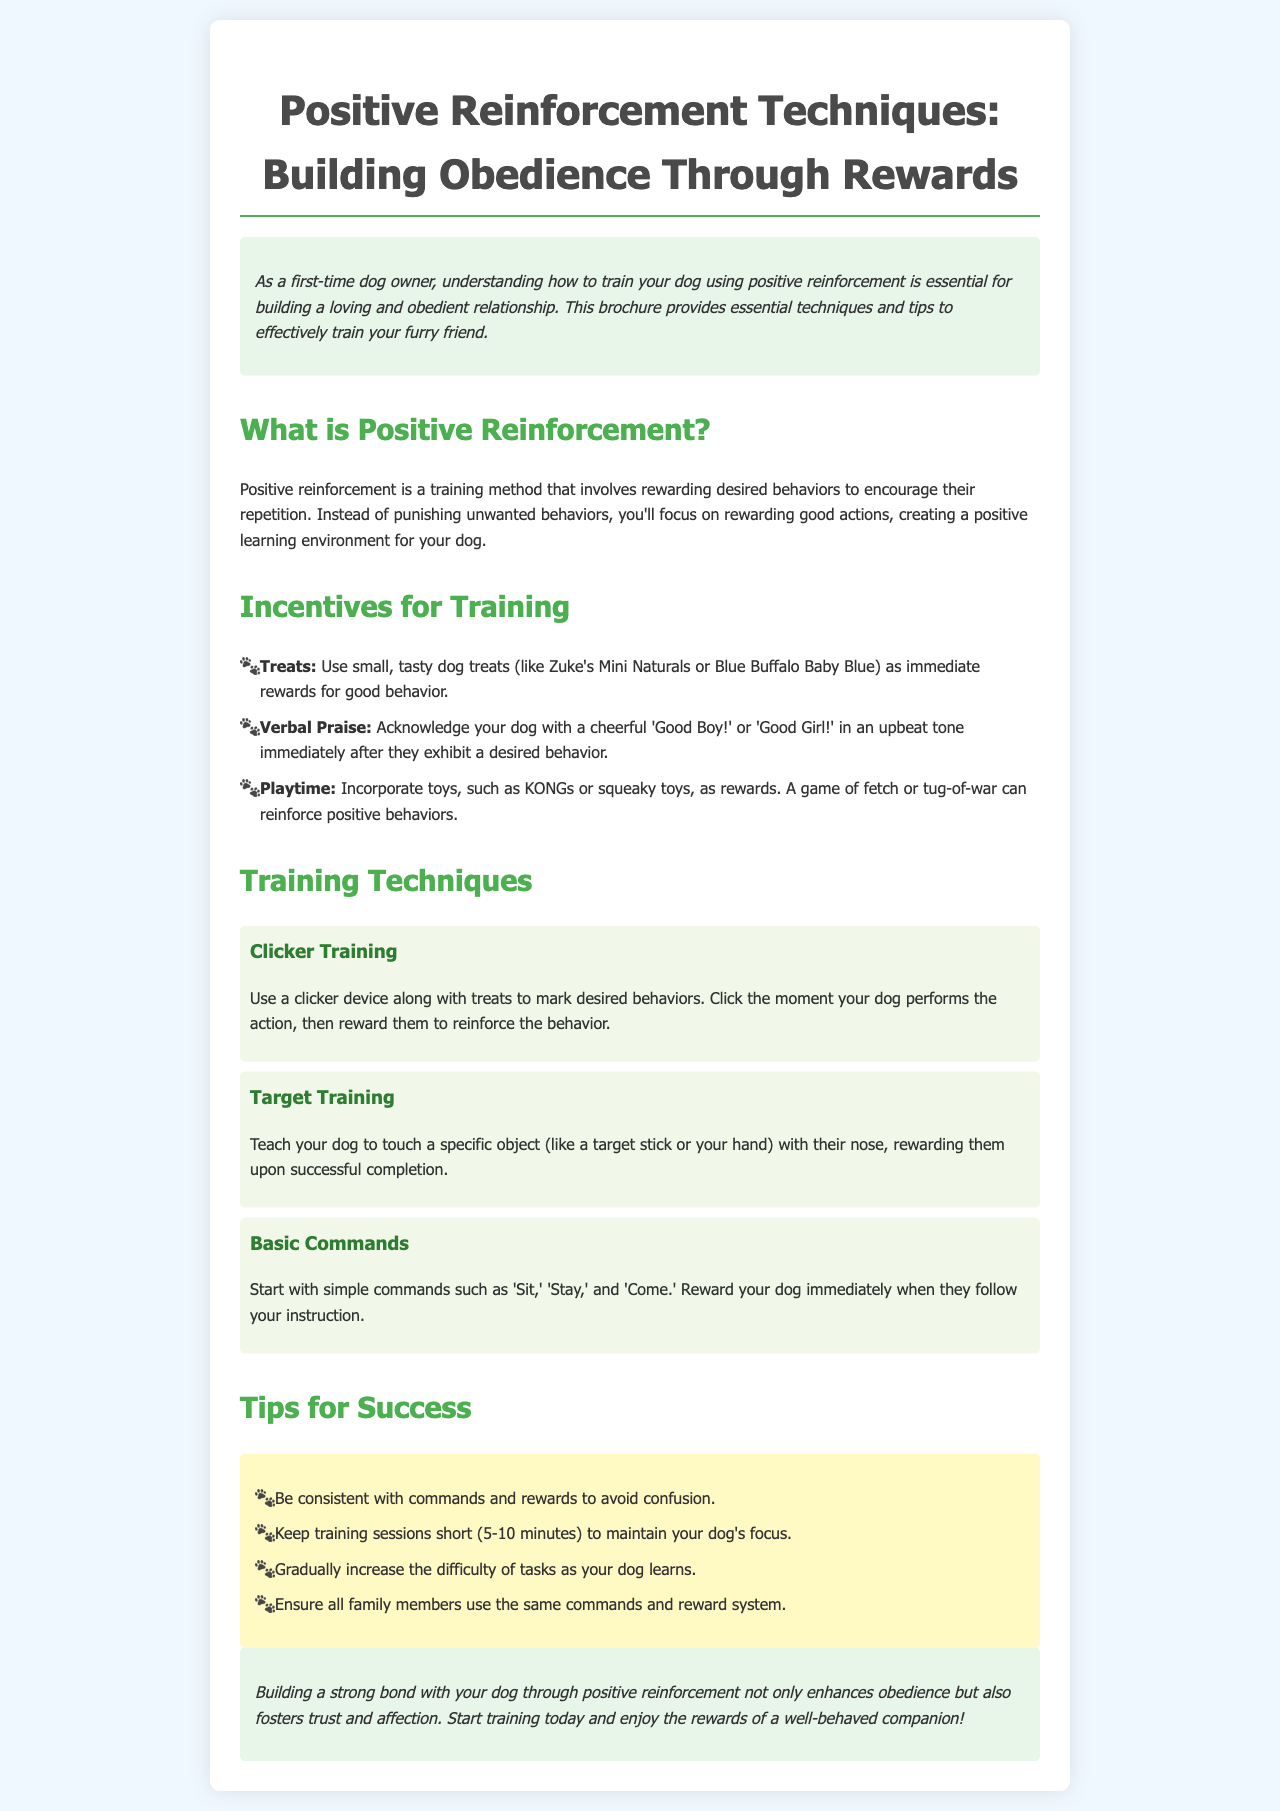What is positive reinforcement? Positive reinforcement is a training method that involves rewarding desired behaviors to encourage their repetition.
Answer: A training method involving rewards What are some treats mentioned for training? The brochure lists specific small, tasty dog treats like Zuke's Mini Naturals or Blue Buffalo Baby Blue as rewards.
Answer: Zuke's Mini Naturals, Blue Buffalo Baby Blue What is one technique for building obedience mentioned? The document highlights several techniques, one of which is clicker training, used to mark desired behaviors.
Answer: Clicker Training What is an example of verbal praise? The brochure provides examples of verbal encouragement such as 'Good Boy!' or 'Good Girl!' to acknowledge desired behavior.
Answer: Good Boy! or Good Girl! How long should training sessions be? The brochure advises keeping training sessions short to maintain focus, specifying a duration of 5-10 minutes.
Answer: 5-10 minutes What is the primary focus of positive reinforcement? The goal of positive reinforcement is to create a positive learning environment by rewarding good actions rather than punishing unwanted behaviors.
Answer: Rewarding good actions Name one incentive for training. The document lists several incentives, including treats, verbal praise, and playtime as means to encourage training.
Answer: Treats How can you increase the difficulty of tasks? The brochure suggests gradually increasing the difficulty of tasks as your dog learns to keep them engaged and challenged.
Answer: Gradually increase difficulty What should all family members do regarding commands? The document emphasizes that all family members should use the same commands and reward system to avoid confusion in training.
Answer: Use the same commands and reward system 